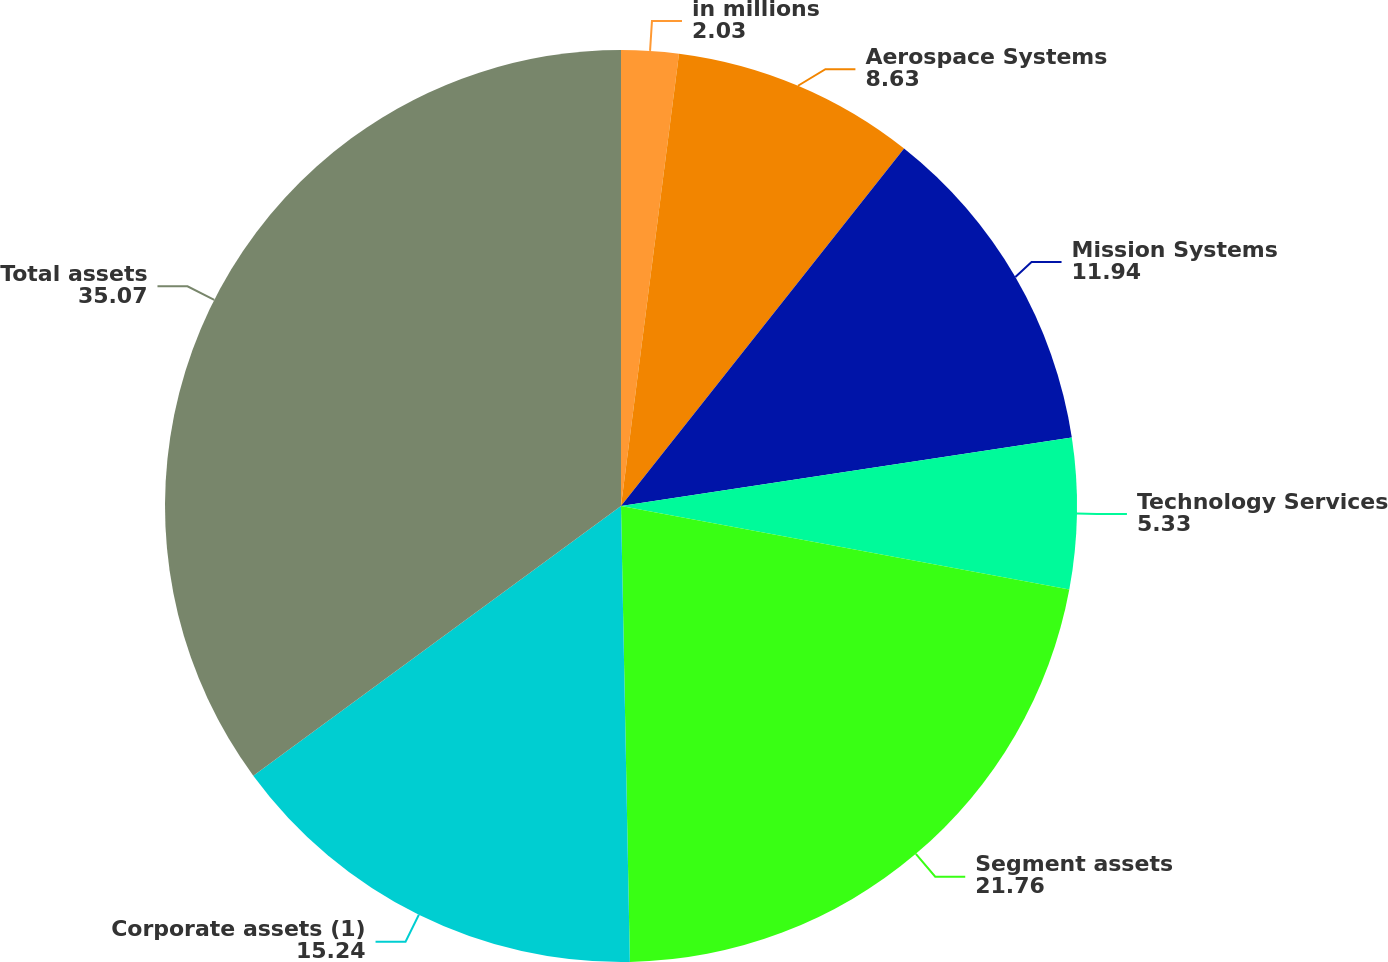Convert chart to OTSL. <chart><loc_0><loc_0><loc_500><loc_500><pie_chart><fcel>in millions<fcel>Aerospace Systems<fcel>Mission Systems<fcel>Technology Services<fcel>Segment assets<fcel>Corporate assets (1)<fcel>Total assets<nl><fcel>2.03%<fcel>8.63%<fcel>11.94%<fcel>5.33%<fcel>21.76%<fcel>15.24%<fcel>35.07%<nl></chart> 